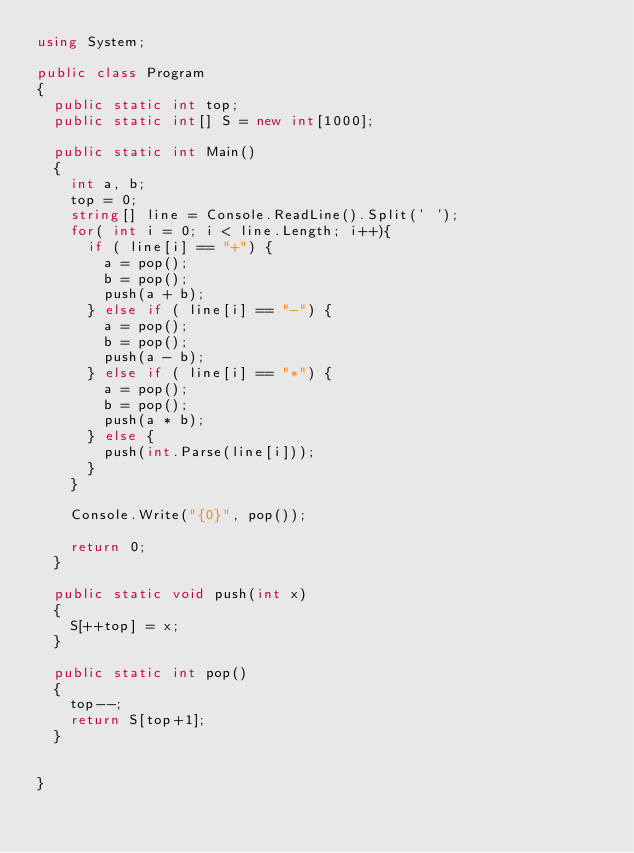<code> <loc_0><loc_0><loc_500><loc_500><_C#_>using System;

public class Program
{
	public static int top;
	public static int[] S = new int[1000];

	public static int Main()
	{
		int a, b;
		top = 0;
		string[] line = Console.ReadLine().Split(' ');
		for( int i = 0; i < line.Length; i++){
			if ( line[i] == "+") {
				a = pop();
				b = pop();
				push(a + b);
			} else if ( line[i] == "-") {
				a = pop();
				b = pop();
				push(a - b);
			} else if ( line[i] == "*") {
				a = pop();
				b = pop();
				push(a * b);
			} else {
				push(int.Parse(line[i]));
			}
		}

		Console.Write("{0}", pop());

		return 0;
	}

	public static void push(int x)
	{
		S[++top] = x;
	}

	public static int pop()
	{
		top--;
		return S[top+1];
	}


}</code> 